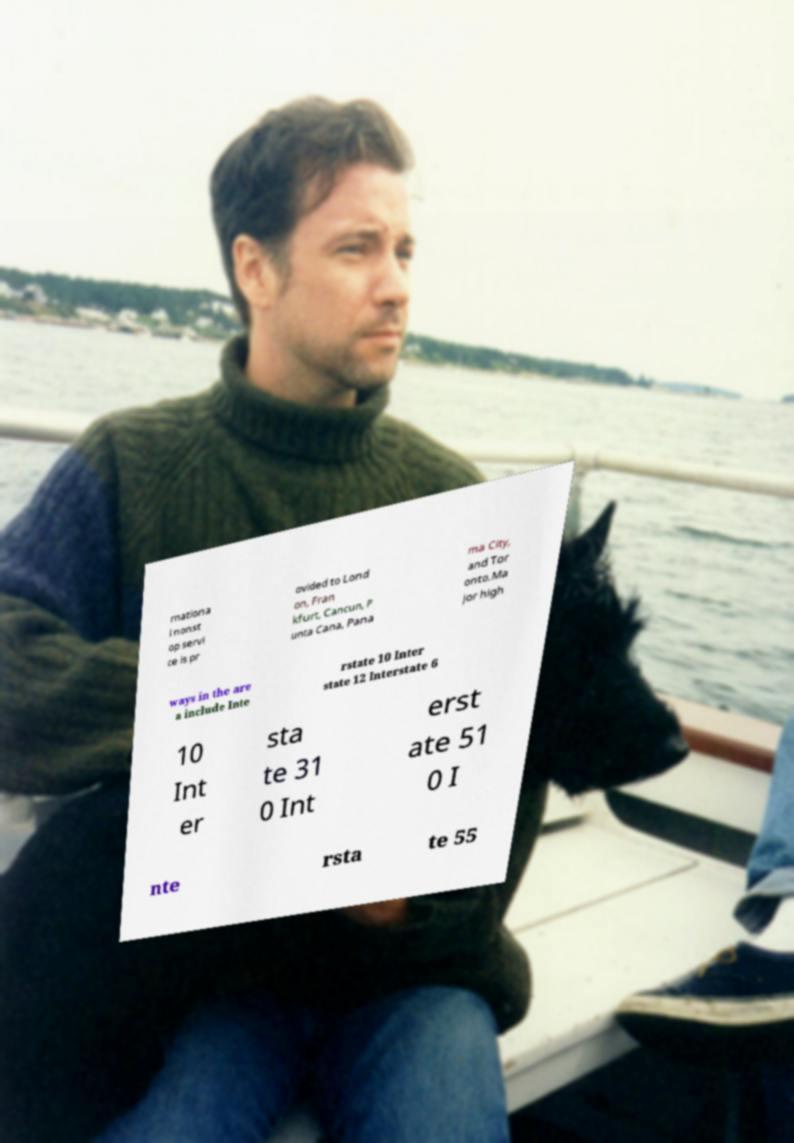Can you accurately transcribe the text from the provided image for me? rnationa l nonst op servi ce is pr ovided to Lond on, Fran kfurt, Cancun, P unta Cana, Pana ma City, and Tor onto.Ma jor high ways in the are a include Inte rstate 10 Inter state 12 Interstate 6 10 Int er sta te 31 0 Int erst ate 51 0 I nte rsta te 55 